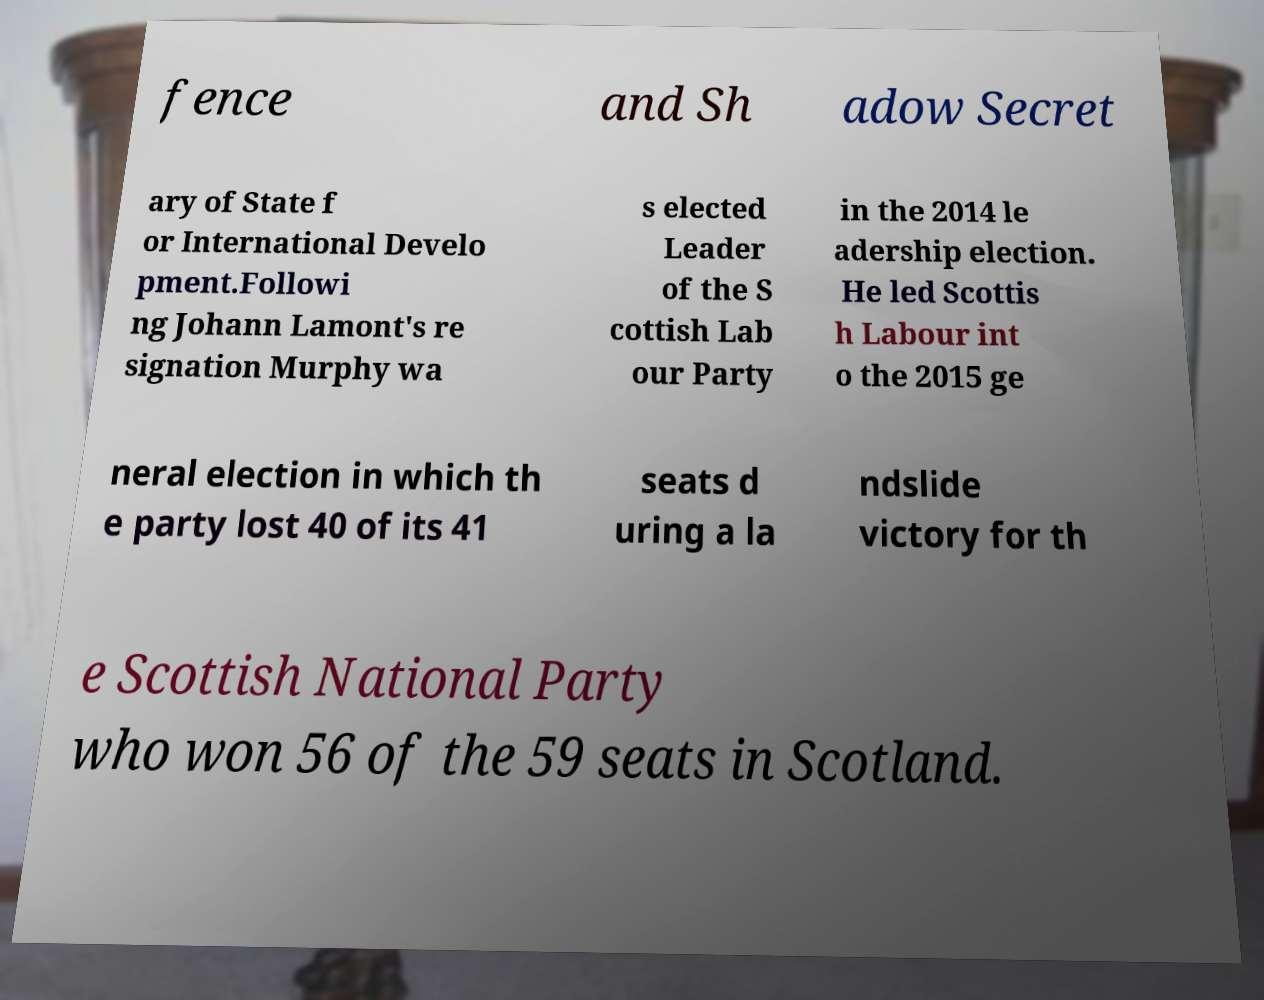Can you accurately transcribe the text from the provided image for me? fence and Sh adow Secret ary of State f or International Develo pment.Followi ng Johann Lamont's re signation Murphy wa s elected Leader of the S cottish Lab our Party in the 2014 le adership election. He led Scottis h Labour int o the 2015 ge neral election in which th e party lost 40 of its 41 seats d uring a la ndslide victory for th e Scottish National Party who won 56 of the 59 seats in Scotland. 